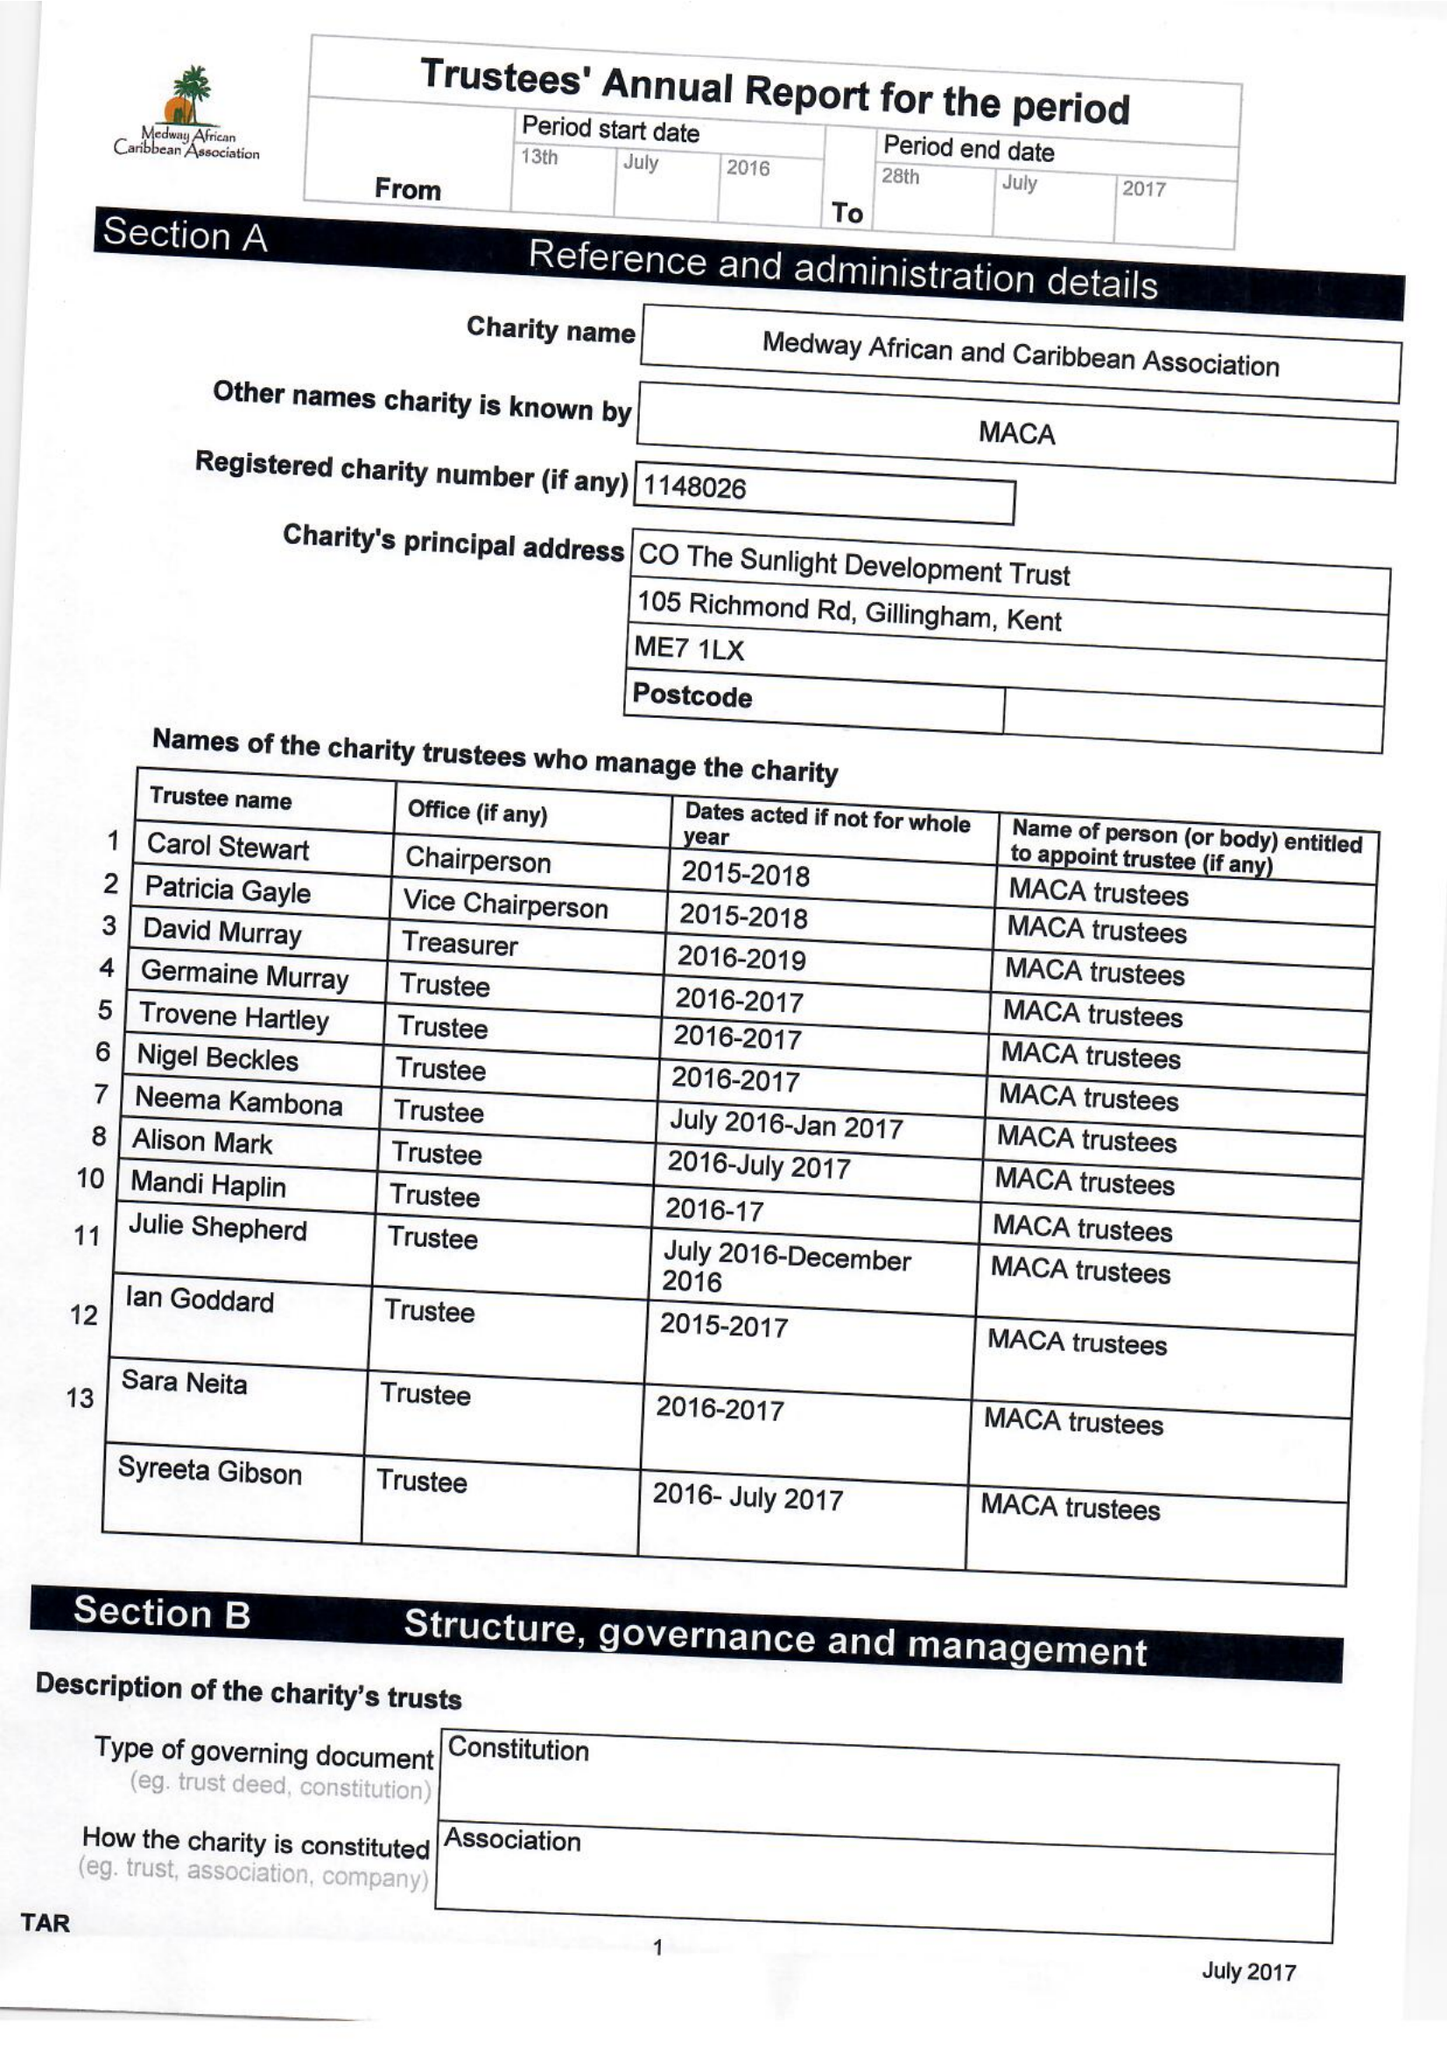What is the value for the spending_annually_in_british_pounds?
Answer the question using a single word or phrase. 10365.00 